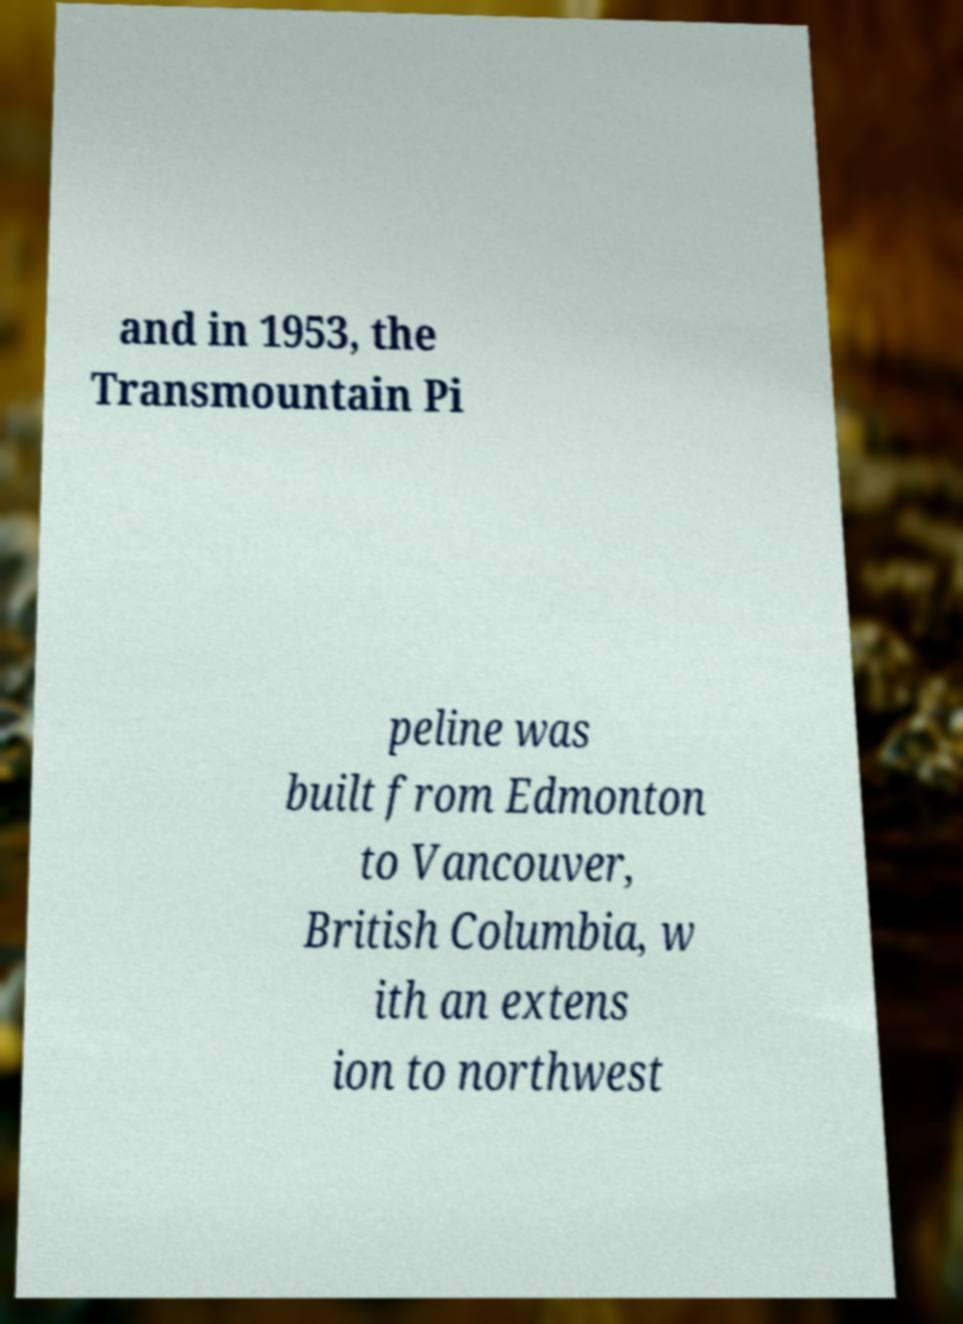For documentation purposes, I need the text within this image transcribed. Could you provide that? and in 1953, the Transmountain Pi peline was built from Edmonton to Vancouver, British Columbia, w ith an extens ion to northwest 